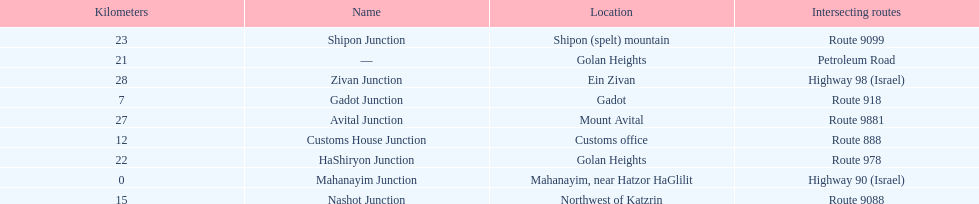What is the total kilometers that separates the mahanayim junction and the shipon junction? 23. 